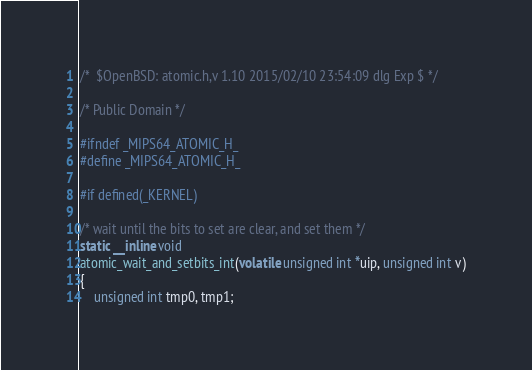<code> <loc_0><loc_0><loc_500><loc_500><_C_>/*	$OpenBSD: atomic.h,v 1.10 2015/02/10 23:54:09 dlg Exp $	*/

/* Public Domain */

#ifndef _MIPS64_ATOMIC_H_
#define _MIPS64_ATOMIC_H_

#if defined(_KERNEL)

/* wait until the bits to set are clear, and set them */
static __inline void
atomic_wait_and_setbits_int(volatile unsigned int *uip, unsigned int v)
{
	unsigned int tmp0, tmp1;
</code> 